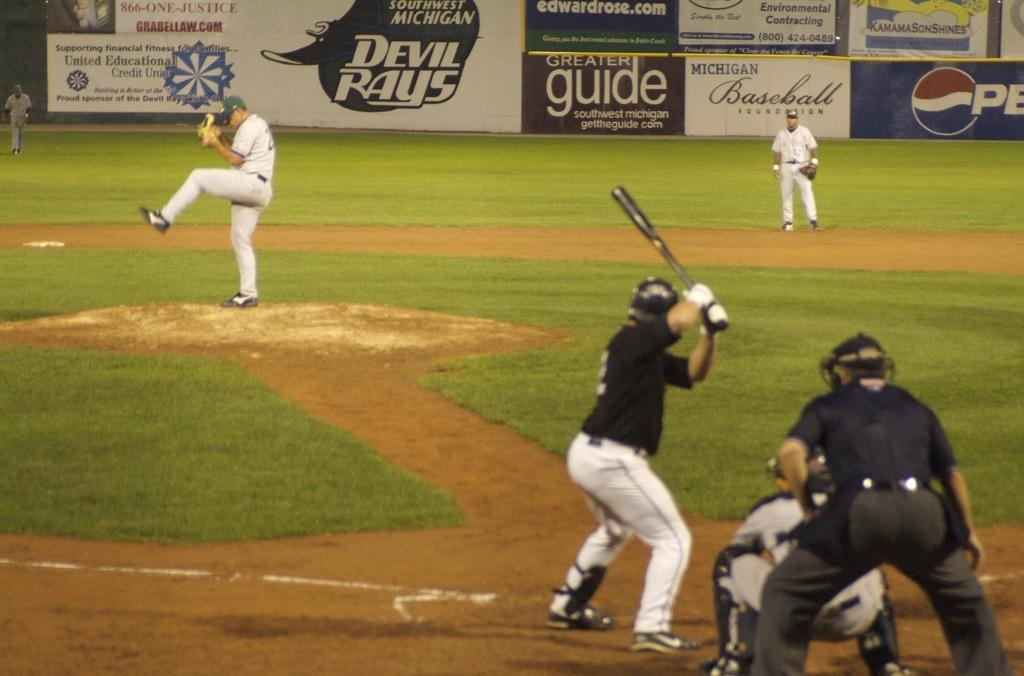<image>
Present a compact description of the photo's key features. Devil Rays play a baseball game in the middle of the day. 